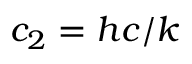Convert formula to latex. <formula><loc_0><loc_0><loc_500><loc_500>c _ { 2 } = h c / k</formula> 